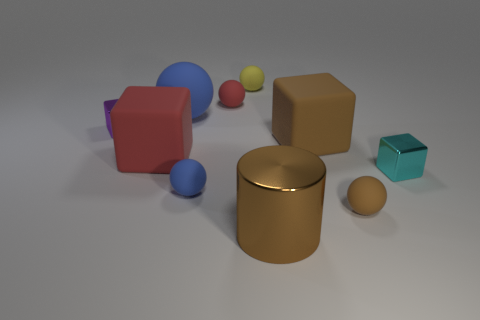Are there any other things that have the same shape as the small red object?
Give a very brief answer. Yes. Are there the same number of cyan metal things that are behind the tiny red rubber sphere and brown objects?
Offer a very short reply. No. Is the color of the shiny cylinder the same as the large block to the right of the metal cylinder?
Offer a very short reply. Yes. What is the color of the metallic thing that is both in front of the brown rubber block and behind the brown shiny object?
Give a very brief answer. Cyan. There is a yellow sphere that is behind the small purple metal object; how many tiny cyan cubes are to the left of it?
Your answer should be very brief. 0. Is there another metallic thing of the same shape as the purple metal object?
Keep it short and to the point. Yes. Do the tiny object that is on the left side of the large sphere and the small metal object that is to the right of the large red thing have the same shape?
Provide a succinct answer. Yes. What number of objects are tiny green things or metallic cylinders?
Keep it short and to the point. 1. There is a red thing that is the same shape as the cyan thing; what size is it?
Your response must be concise. Large. Are there more rubber blocks on the right side of the big brown metal cylinder than tiny cylinders?
Keep it short and to the point. Yes. 